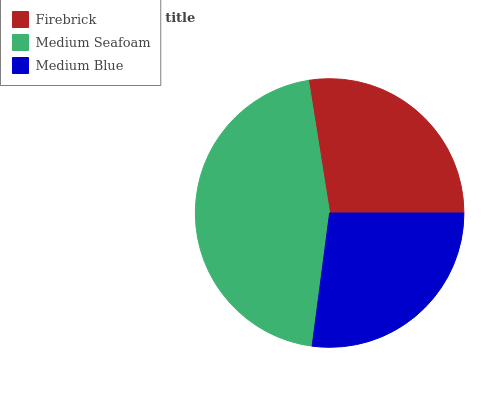Is Medium Blue the minimum?
Answer yes or no. Yes. Is Medium Seafoam the maximum?
Answer yes or no. Yes. Is Medium Seafoam the minimum?
Answer yes or no. No. Is Medium Blue the maximum?
Answer yes or no. No. Is Medium Seafoam greater than Medium Blue?
Answer yes or no. Yes. Is Medium Blue less than Medium Seafoam?
Answer yes or no. Yes. Is Medium Blue greater than Medium Seafoam?
Answer yes or no. No. Is Medium Seafoam less than Medium Blue?
Answer yes or no. No. Is Firebrick the high median?
Answer yes or no. Yes. Is Firebrick the low median?
Answer yes or no. Yes. Is Medium Seafoam the high median?
Answer yes or no. No. Is Medium Seafoam the low median?
Answer yes or no. No. 